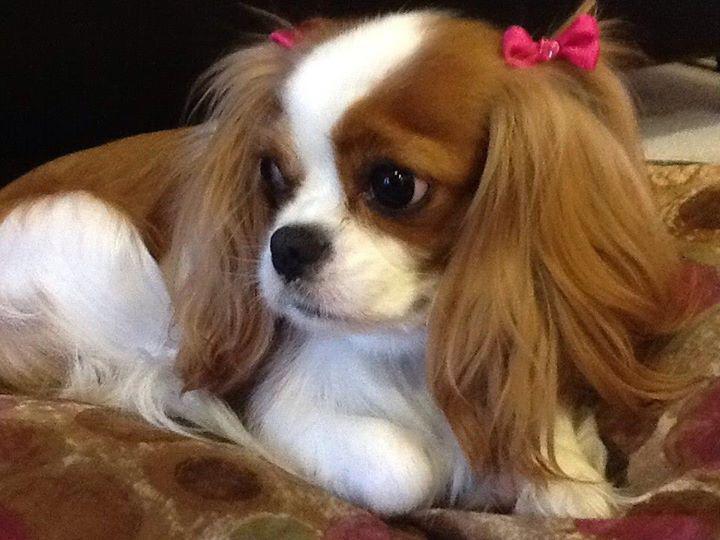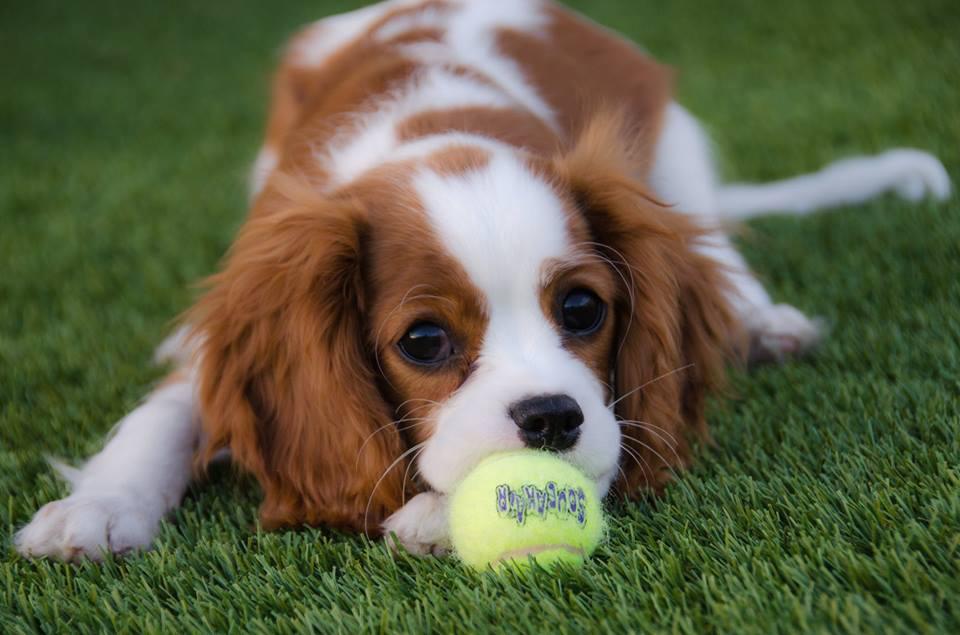The first image is the image on the left, the second image is the image on the right. For the images shown, is this caption "There are two dogs, one that is looking forward and one that is not." true? Answer yes or no. Yes. The first image is the image on the left, the second image is the image on the right. Given the left and right images, does the statement "All the dogs are lying down and one dog has its head facing towards the left side of the image." hold true? Answer yes or no. Yes. 